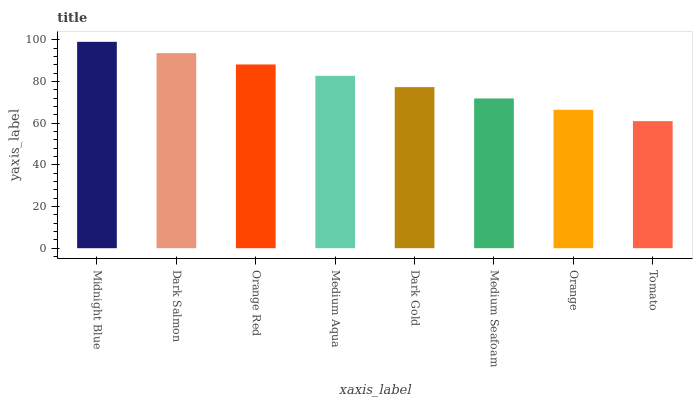Is Tomato the minimum?
Answer yes or no. Yes. Is Midnight Blue the maximum?
Answer yes or no. Yes. Is Dark Salmon the minimum?
Answer yes or no. No. Is Dark Salmon the maximum?
Answer yes or no. No. Is Midnight Blue greater than Dark Salmon?
Answer yes or no. Yes. Is Dark Salmon less than Midnight Blue?
Answer yes or no. Yes. Is Dark Salmon greater than Midnight Blue?
Answer yes or no. No. Is Midnight Blue less than Dark Salmon?
Answer yes or no. No. Is Medium Aqua the high median?
Answer yes or no. Yes. Is Dark Gold the low median?
Answer yes or no. Yes. Is Orange Red the high median?
Answer yes or no. No. Is Medium Seafoam the low median?
Answer yes or no. No. 